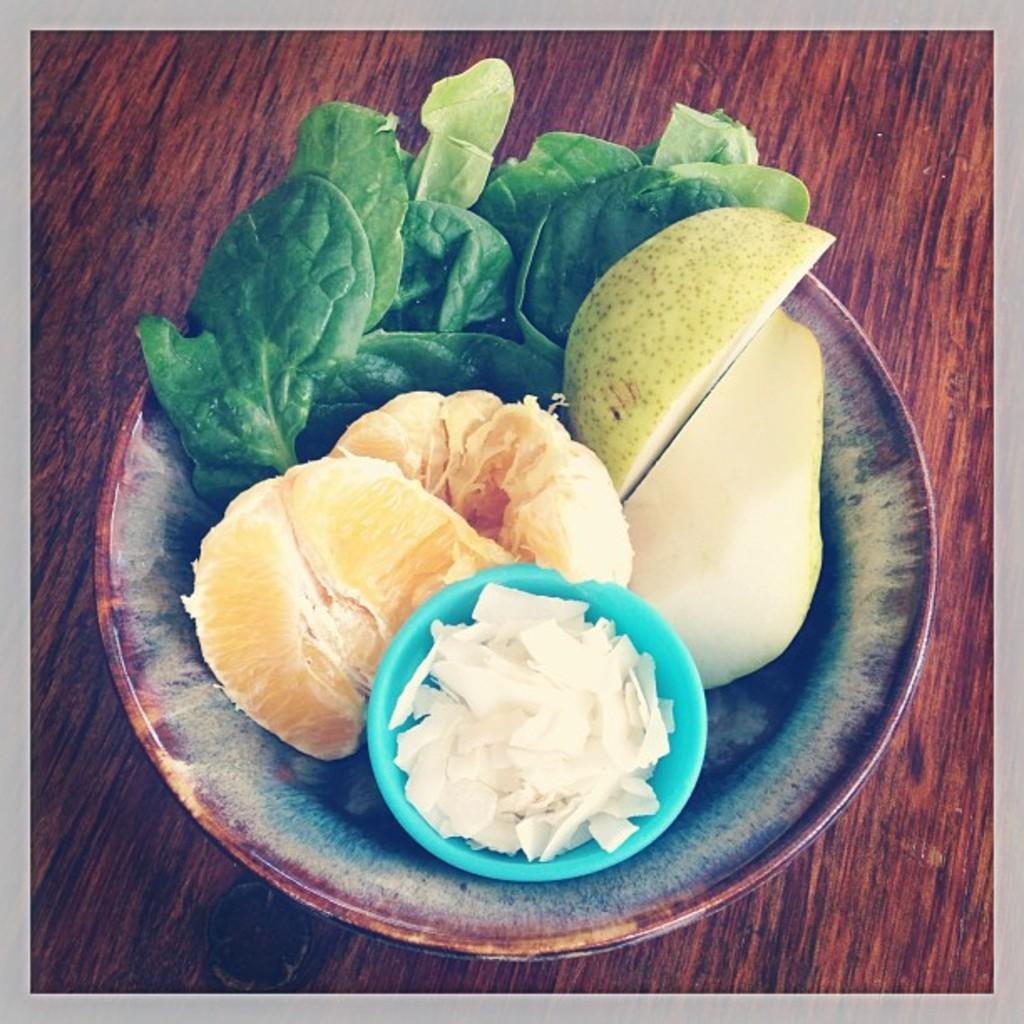What type of table is in the image? There is a wooden table in the image. What is on top of the table? There is a bowl on the table. What is inside the bowl? The bowl contains fruits, leaves, and other food items. What type of noise can be heard coming from the bowl in the image? There is no noise coming from the bowl in the image. Can you see a person interacting with the bowl in the image? There is no person present in the image. 